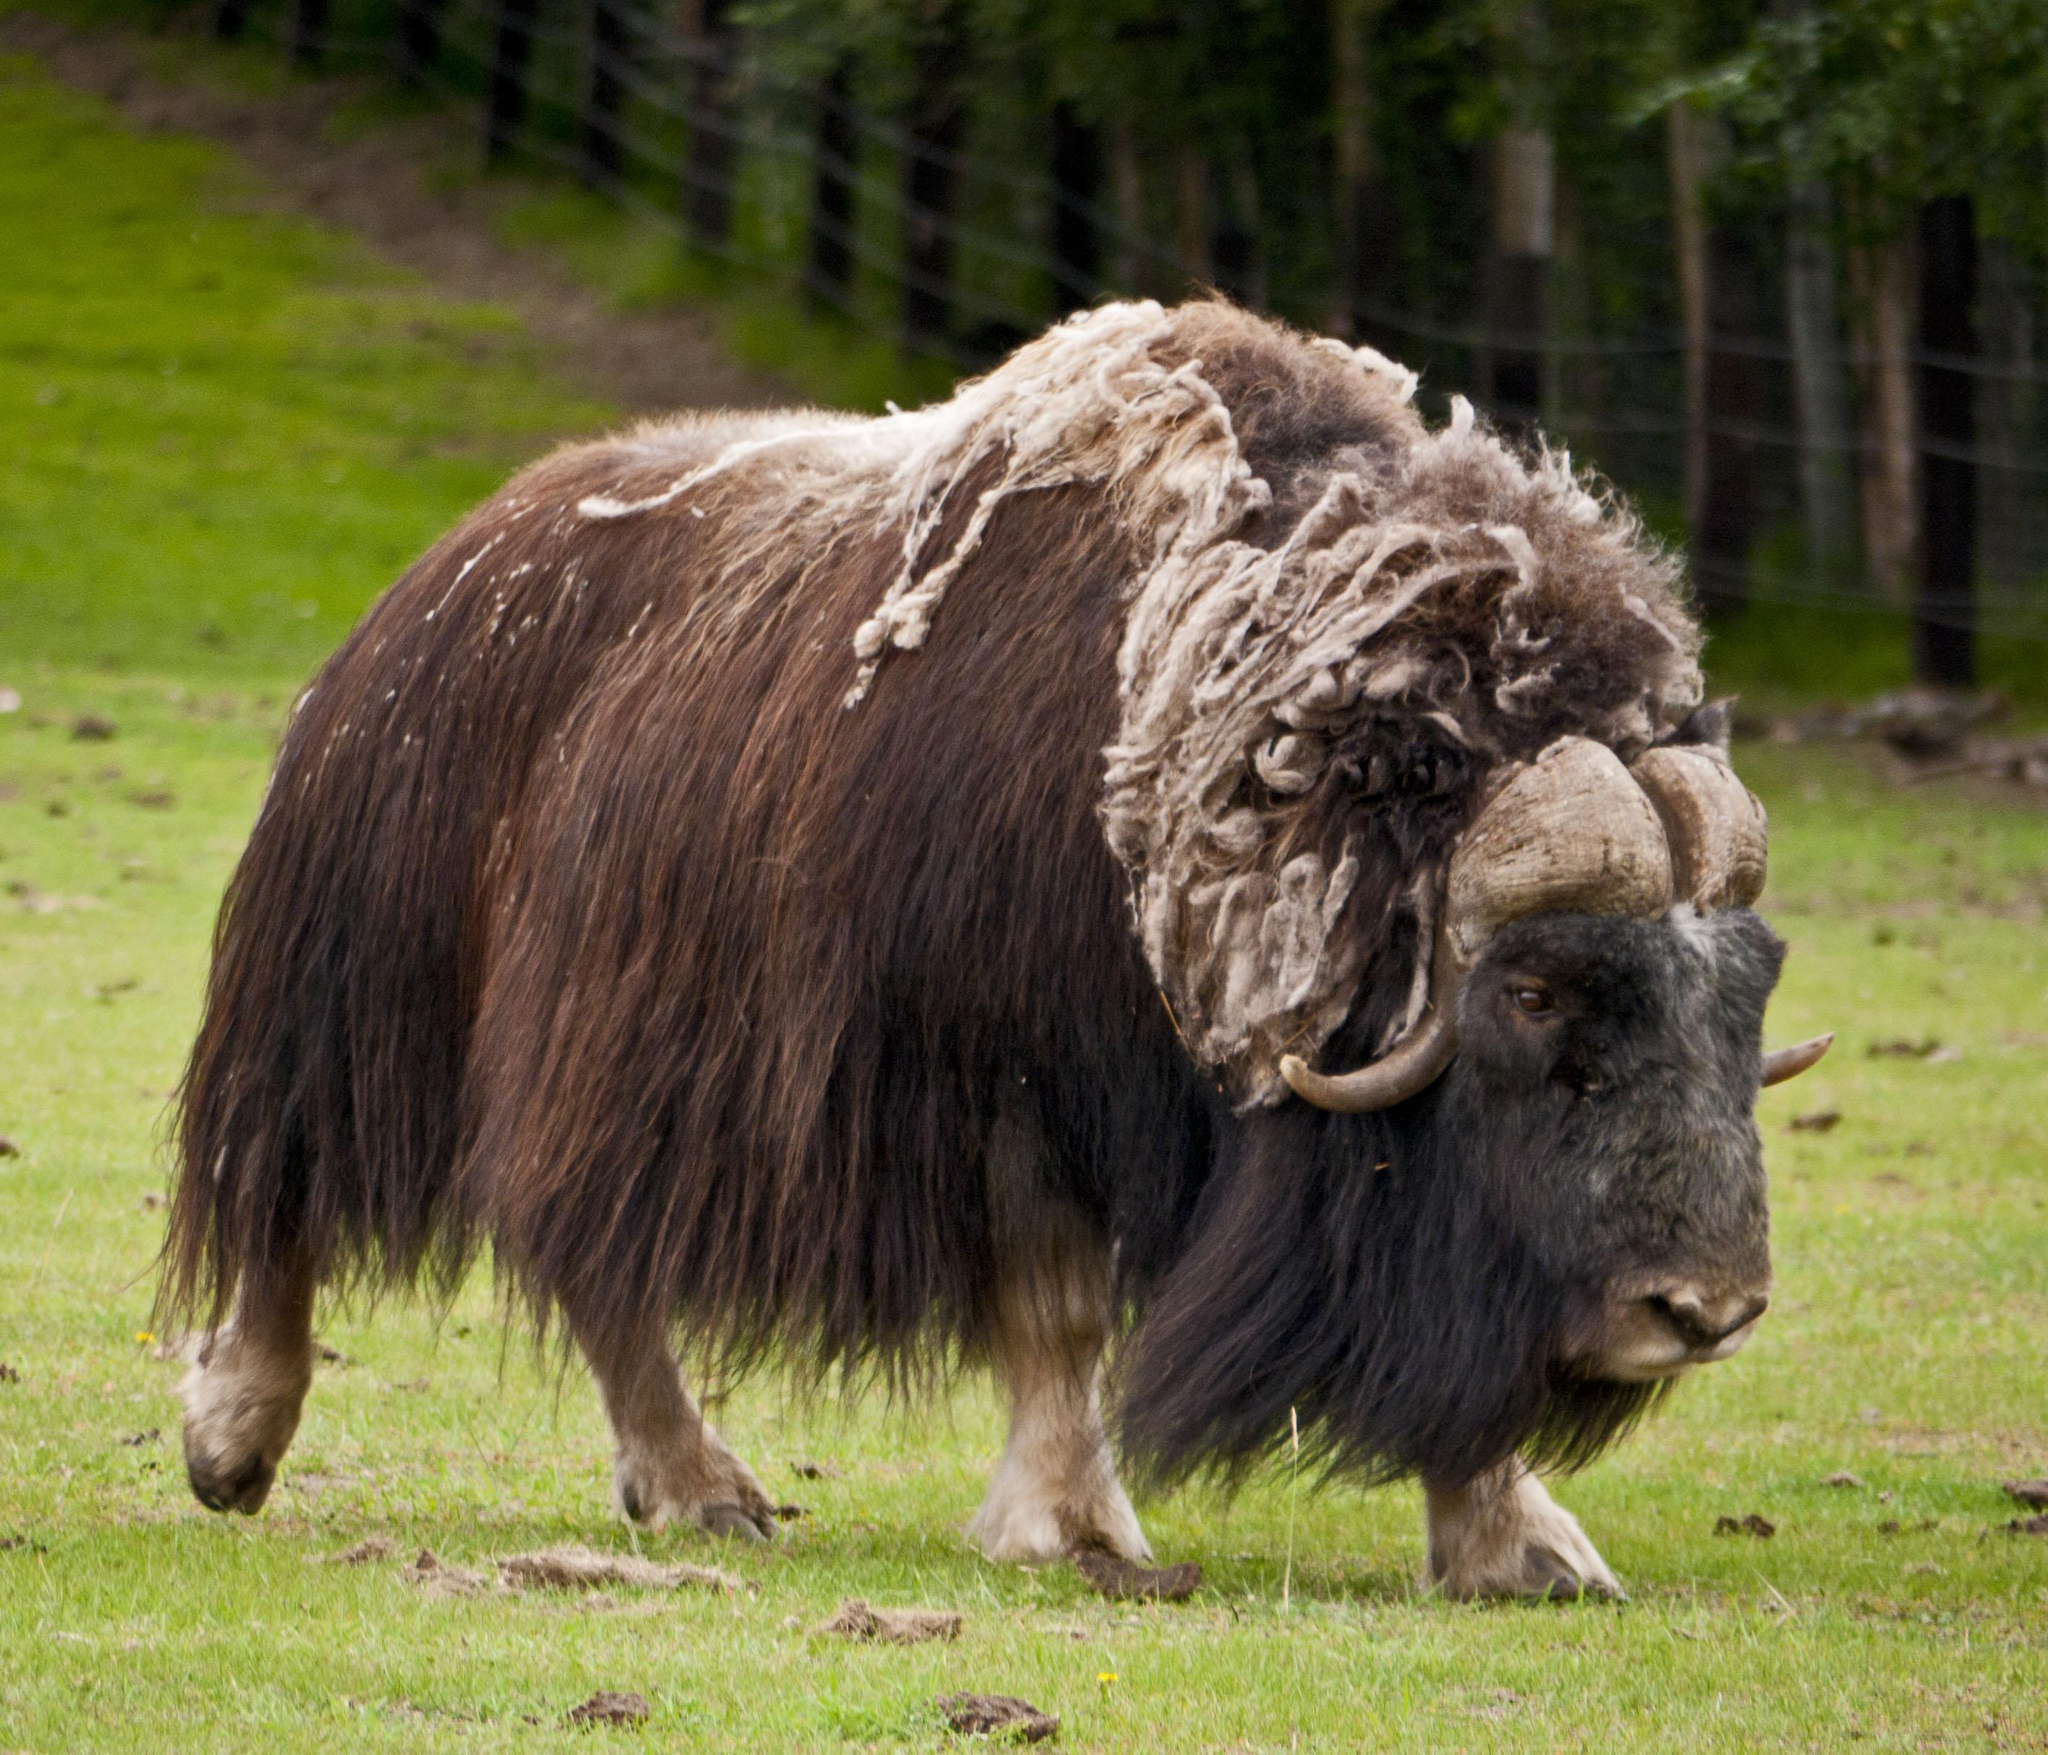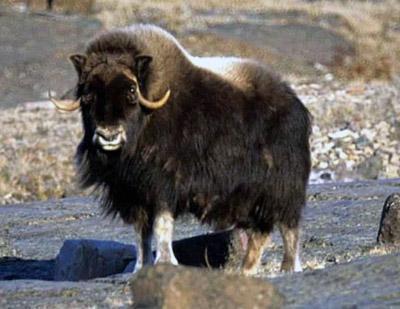The first image is the image on the left, the second image is the image on the right. Considering the images on both sides, is "There are trees in the background of the image on the left." valid? Answer yes or no. Yes. 